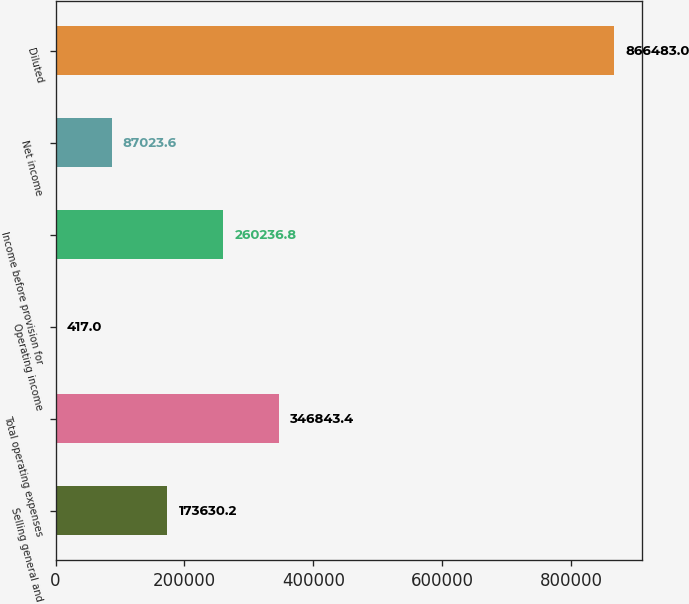Convert chart. <chart><loc_0><loc_0><loc_500><loc_500><bar_chart><fcel>Selling general and<fcel>Total operating expenses<fcel>Operating income<fcel>Income before provision for<fcel>Net income<fcel>Diluted<nl><fcel>173630<fcel>346843<fcel>417<fcel>260237<fcel>87023.6<fcel>866483<nl></chart> 